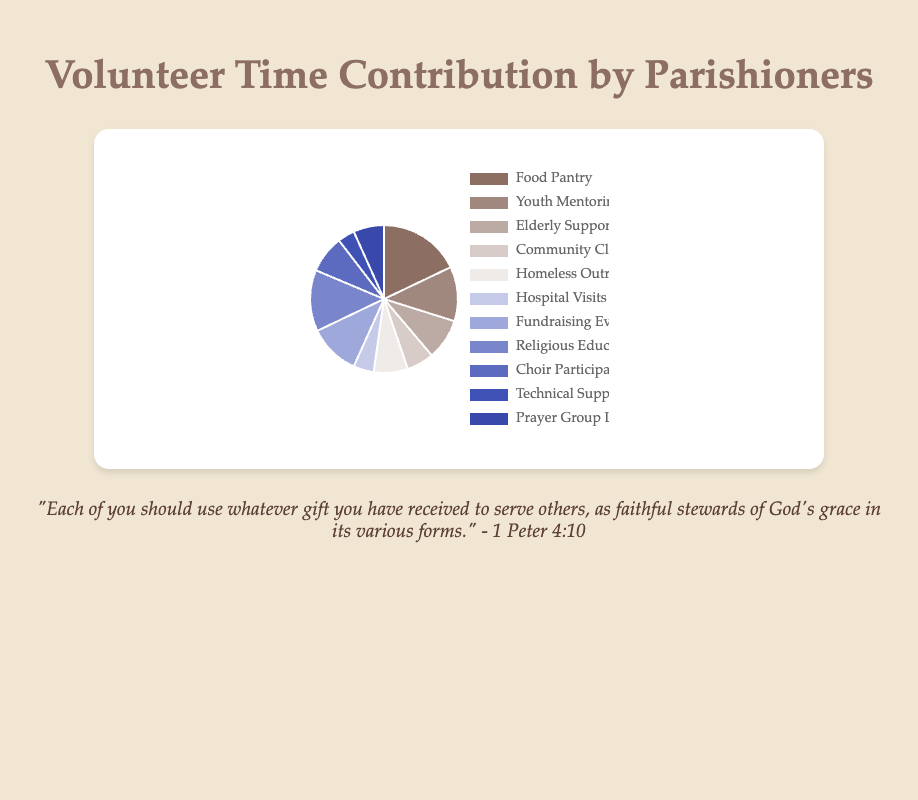Which community service received the most volunteer hours? By looking at the pie chart, identify the segment with the largest proportion. The segment labeled "Food Pantry" clearly has the largest size, indicating it received the most volunteer hours.
Answer: Food Pantry How many hours did the parishioners contribute to Homeless Outreach and Hospital Visits combined? From the chart, we see that Homeless Outreach received 50 hours and Hospital Visits received 30 hours. Adding these together, we get 50 + 30 = 80 hours.
Answer: 80 hours Which activity had fewer volunteer hours: Choir Participation or Fundraising Events? By comparing the sizes of the segments labeled "Choir Participation" and "Fundraising Events," it's clear that "Choir Participation" has fewer hours. Specifically, Choir Participation has 55 hours, while Fundraising Events has 75 hours.
Answer: Choir Participation What is the difference in volunteer hours between Youth Mentoring and Elderly Support? From the chart, Youth Mentoring has 80 hours and Elderly Support has 60 hours. The difference between them is 80 - 60 = 20 hours.
Answer: 20 hours What proportion of the total volunteer hours was dedicated to Community Clean-Up? First, we sum all the hours: 615 total hours. Next, we find the number of hours for Community Clean-Up, which is 40. The proportion is 40 / 615, or approximately 6.5%.
Answer: 6.5% Which service has a smaller contribution: Technical Support for Mass Services or Prayer Group Leadership? Comparing the segments, Technical Support for Mass Services has 25 hours and Prayer Group Leadership has 45 hours, so Technical Support for Mass Services has the smaller contribution.
Answer: Technical Support for Mass Services What service received 90 volunteer hours? By scanning the pie chart for the segment representing 90 hours, we find it is "Religious Education Teaching."
Answer: Religious Education Teaching How do the volunteer hours for Fundraising Events compare to those for Homeless Outreach? From the chart, Fundraising Events has 75 volunteer hours, while Homeless Outreach has 50 hours. Thus, Fundraising Events has more hours.
Answer: Fundraising Events What is the average number of volunteer hours per community service? Summing all the hours: 615 hours, then dividing by the number of services: 11, the average is 615 / 11 ≈ 55.9 hours.
Answer: 55.9 hours In terms of volunteer hours, which is greater: Elderly Support or Choir Participation? Elderly Support has 60 hours, while Choir Participation has 55 hours, making Elderly Support greater in terms of volunteer hours.
Answer: Elderly Support 